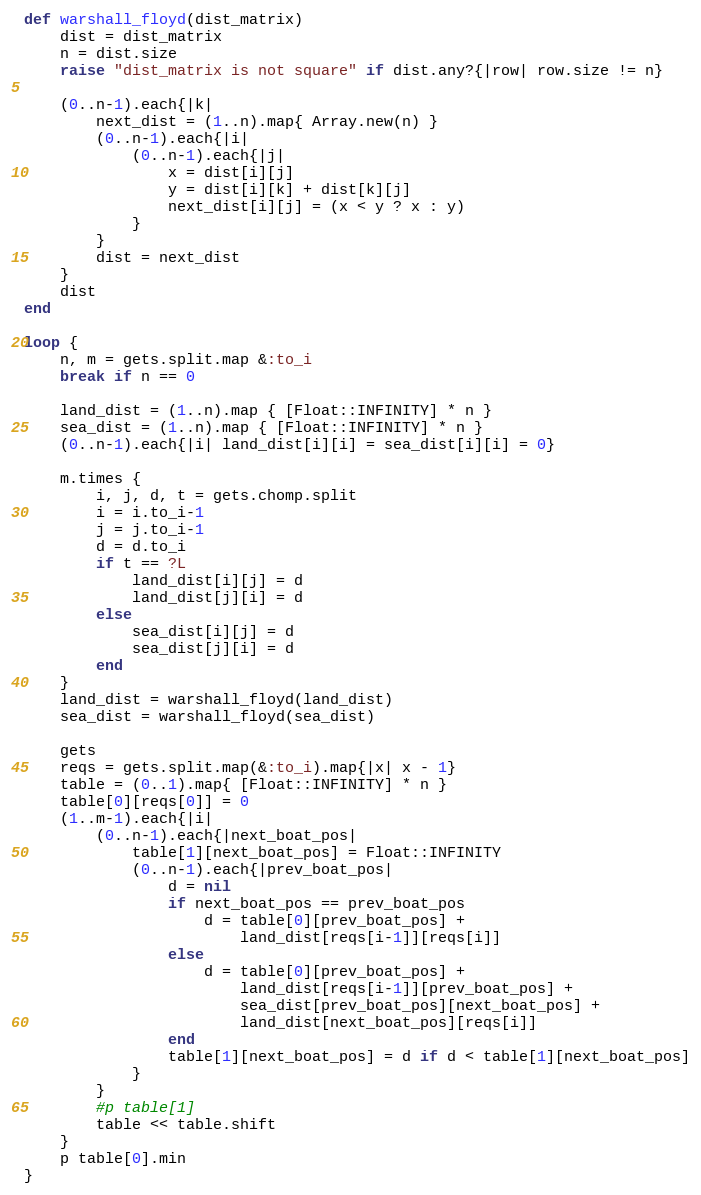<code> <loc_0><loc_0><loc_500><loc_500><_Ruby_>def warshall_floyd(dist_matrix)
	dist = dist_matrix
	n = dist.size
	raise "dist_matrix is not square" if dist.any?{|row| row.size != n}

	(0..n-1).each{|k|
		next_dist = (1..n).map{ Array.new(n) }	
		(0..n-1).each{|i|
			(0..n-1).each{|j|
				x = dist[i][j]
				y = dist[i][k] + dist[k][j]
				next_dist[i][j] = (x < y ? x : y)
			}
		}
		dist = next_dist
	}
	dist
end

loop {
	n, m = gets.split.map &:to_i
	break if n == 0

	land_dist = (1..n).map { [Float::INFINITY] * n }
	sea_dist = (1..n).map { [Float::INFINITY] * n }
	(0..n-1).each{|i| land_dist[i][i] = sea_dist[i][i] = 0}

	m.times {
		i, j, d, t = gets.chomp.split
		i = i.to_i-1
		j = j.to_i-1
		d = d.to_i
		if t == ?L
			land_dist[i][j] = d
			land_dist[j][i] = d
		else
			sea_dist[i][j] = d
			sea_dist[j][i] = d
		end
	}
	land_dist = warshall_floyd(land_dist)
	sea_dist = warshall_floyd(sea_dist)

	gets
	reqs = gets.split.map(&:to_i).map{|x| x - 1}
	table = (0..1).map{ [Float::INFINITY] * n }
	table[0][reqs[0]] = 0
	(1..m-1).each{|i|
		(0..n-1).each{|next_boat_pos|
			table[1][next_boat_pos] = Float::INFINITY
			(0..n-1).each{|prev_boat_pos|
				d = nil
				if next_boat_pos == prev_boat_pos
					d = table[0][prev_boat_pos] + 
				        land_dist[reqs[i-1]][reqs[i]]
				else
					d = table[0][prev_boat_pos] + 
				        land_dist[reqs[i-1]][prev_boat_pos] + 
				        sea_dist[prev_boat_pos][next_boat_pos] +
				        land_dist[next_boat_pos][reqs[i]]
				end
				table[1][next_boat_pos] = d if d < table[1][next_boat_pos]
			}
		}
		#p table[1]
		table << table.shift
	}
	p table[0].min
}</code> 